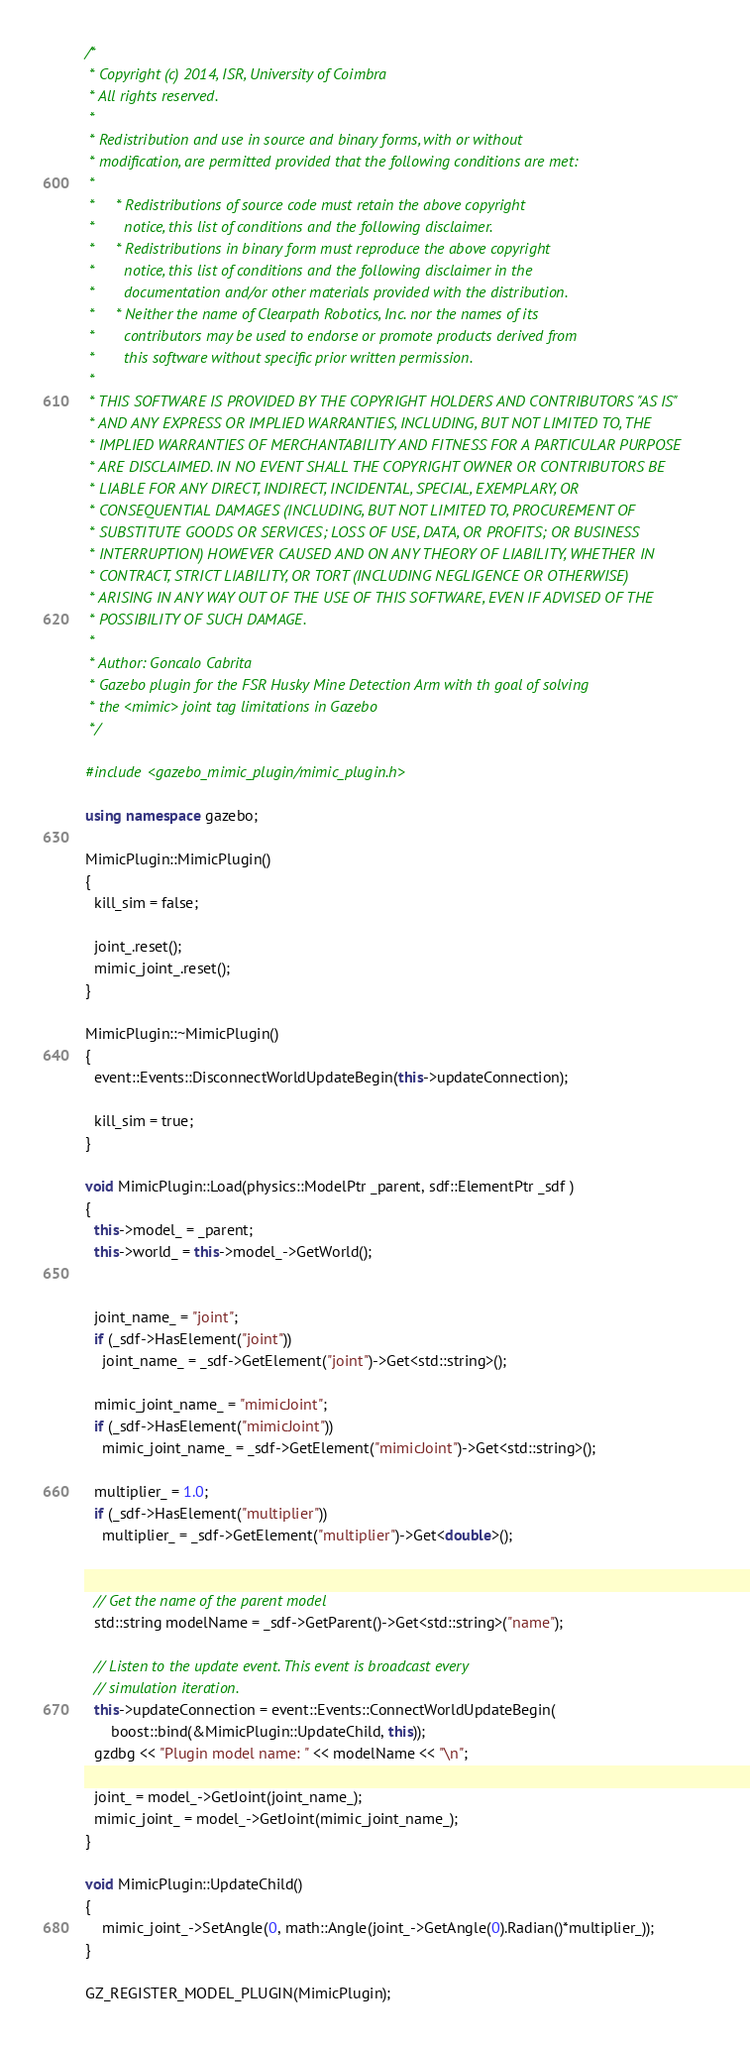Convert code to text. <code><loc_0><loc_0><loc_500><loc_500><_C++_>/*
 * Copyright (c) 2014, ISR, University of Coimbra
 * All rights reserved.
 *
 * Redistribution and use in source and binary forms, with or without
 * modification, are permitted provided that the following conditions are met:
 *
 *     * Redistributions of source code must retain the above copyright
 *       notice, this list of conditions and the following disclaimer.
 *     * Redistributions in binary form must reproduce the above copyright
 *       notice, this list of conditions and the following disclaimer in the
 *       documentation and/or other materials provided with the distribution.
 *     * Neither the name of Clearpath Robotics, Inc. nor the names of its
 *       contributors may be used to endorse or promote products derived from
 *       this software without specific prior written permission.
 *
 * THIS SOFTWARE IS PROVIDED BY THE COPYRIGHT HOLDERS AND CONTRIBUTORS "AS IS"
 * AND ANY EXPRESS OR IMPLIED WARRANTIES, INCLUDING, BUT NOT LIMITED TO, THE
 * IMPLIED WARRANTIES OF MERCHANTABILITY AND FITNESS FOR A PARTICULAR PURPOSE
 * ARE DISCLAIMED. IN NO EVENT SHALL THE COPYRIGHT OWNER OR CONTRIBUTORS BE
 * LIABLE FOR ANY DIRECT, INDIRECT, INCIDENTAL, SPECIAL, EXEMPLARY, OR
 * CONSEQUENTIAL DAMAGES (INCLUDING, BUT NOT LIMITED TO, PROCUREMENT OF
 * SUBSTITUTE GOODS OR SERVICES; LOSS OF USE, DATA, OR PROFITS; OR BUSINESS
 * INTERRUPTION) HOWEVER CAUSED AND ON ANY THEORY OF LIABILITY, WHETHER IN
 * CONTRACT, STRICT LIABILITY, OR TORT (INCLUDING NEGLIGENCE OR OTHERWISE)
 * ARISING IN ANY WAY OUT OF THE USE OF THIS SOFTWARE, EVEN IF ADVISED OF THE
 * POSSIBILITY OF SUCH DAMAGE.
 *
 * Author: Goncalo Cabrita
 * Gazebo plugin for the FSR Husky Mine Detection Arm with th goal of solving
 * the <mimic> joint tag limitations in Gazebo
 */

#include <gazebo_mimic_plugin/mimic_plugin.h>

using namespace gazebo;

MimicPlugin::MimicPlugin()
{
  kill_sim = false;

  joint_.reset();
  mimic_joint_.reset();
}

MimicPlugin::~MimicPlugin()
{
  event::Events::DisconnectWorldUpdateBegin(this->updateConnection);

  kill_sim = true;
}

void MimicPlugin::Load(physics::ModelPtr _parent, sdf::ElementPtr _sdf )
{
  this->model_ = _parent;
  this->world_ = this->model_->GetWorld();


  joint_name_ = "joint";
  if (_sdf->HasElement("joint"))
    joint_name_ = _sdf->GetElement("joint")->Get<std::string>();

  mimic_joint_name_ = "mimicJoint";
  if (_sdf->HasElement("mimicJoint"))
    mimic_joint_name_ = _sdf->GetElement("mimicJoint")->Get<std::string>();

  multiplier_ = 1.0;
  if (_sdf->HasElement("multiplier"))
    multiplier_ = _sdf->GetElement("multiplier")->Get<double>();


  // Get the name of the parent model
  std::string modelName = _sdf->GetParent()->Get<std::string>("name");

  // Listen to the update event. This event is broadcast every
  // simulation iteration.
  this->updateConnection = event::Events::ConnectWorldUpdateBegin(
      boost::bind(&MimicPlugin::UpdateChild, this));
  gzdbg << "Plugin model name: " << modelName << "\n";

  joint_ = model_->GetJoint(joint_name_);
  mimic_joint_ = model_->GetJoint(mimic_joint_name_);
}

void MimicPlugin::UpdateChild()
{
    mimic_joint_->SetAngle(0, math::Angle(joint_->GetAngle(0).Radian()*multiplier_));
}

GZ_REGISTER_MODEL_PLUGIN(MimicPlugin);
</code> 